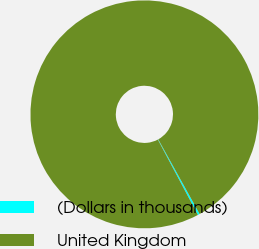Convert chart to OTSL. <chart><loc_0><loc_0><loc_500><loc_500><pie_chart><fcel>(Dollars in thousands)<fcel>United Kingdom<nl><fcel>0.27%<fcel>99.73%<nl></chart> 